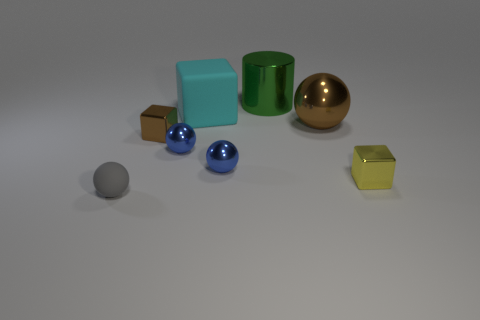There is a object that is the same color as the large metallic ball; what is its size?
Keep it short and to the point. Small. Are there any large cylinders that have the same color as the large matte object?
Offer a very short reply. No. There is a yellow cube that is made of the same material as the green cylinder; what size is it?
Offer a terse response. Small. How many balls are either small blue metallic things or gray rubber things?
Your response must be concise. 3. Is the number of big purple metallic things greater than the number of large cyan rubber blocks?
Your answer should be compact. No. What number of yellow metallic blocks have the same size as the cylinder?
Your answer should be very brief. 0. There is a object that is the same color as the large metallic sphere; what is its shape?
Provide a short and direct response. Cube. What number of objects are metal objects behind the small yellow metal block or small things?
Your answer should be compact. 7. Are there fewer big green objects than large purple shiny cubes?
Your answer should be compact. No. There is a yellow thing that is the same material as the brown ball; what is its shape?
Offer a very short reply. Cube. 